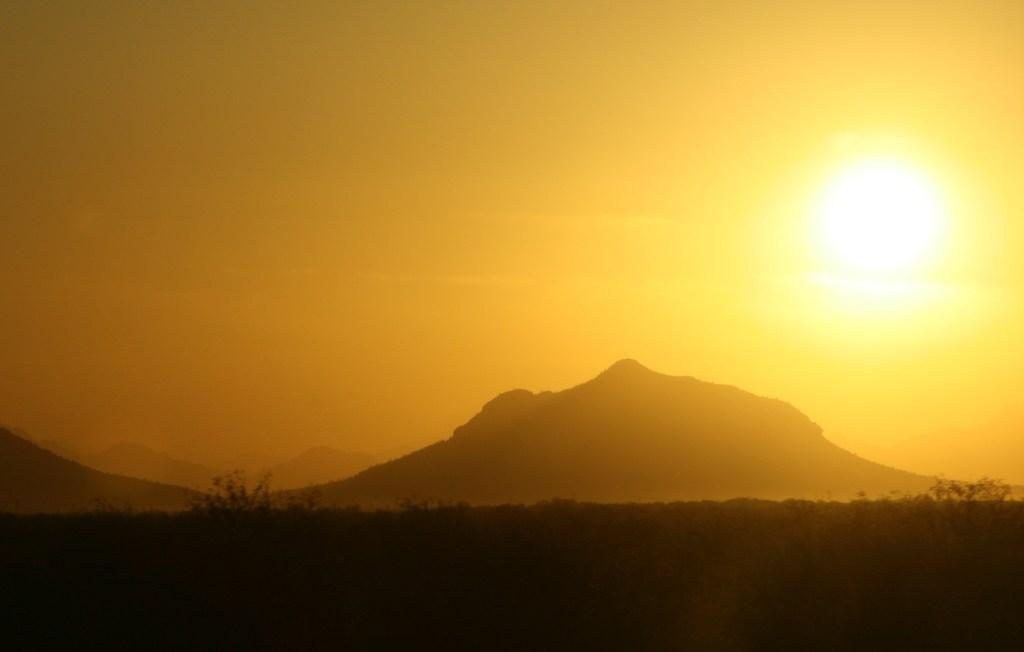What type of living organisms can be seen at the bottom of the image? There are plants in the bottom side of the image. What celestial body is visible on the right side of the image? There is a sun on the right side of the image. How many bricks are stacked on the left side of the image? There are no bricks present in the image. Can you see any mice running around in the image? There are no mice present in the image. 